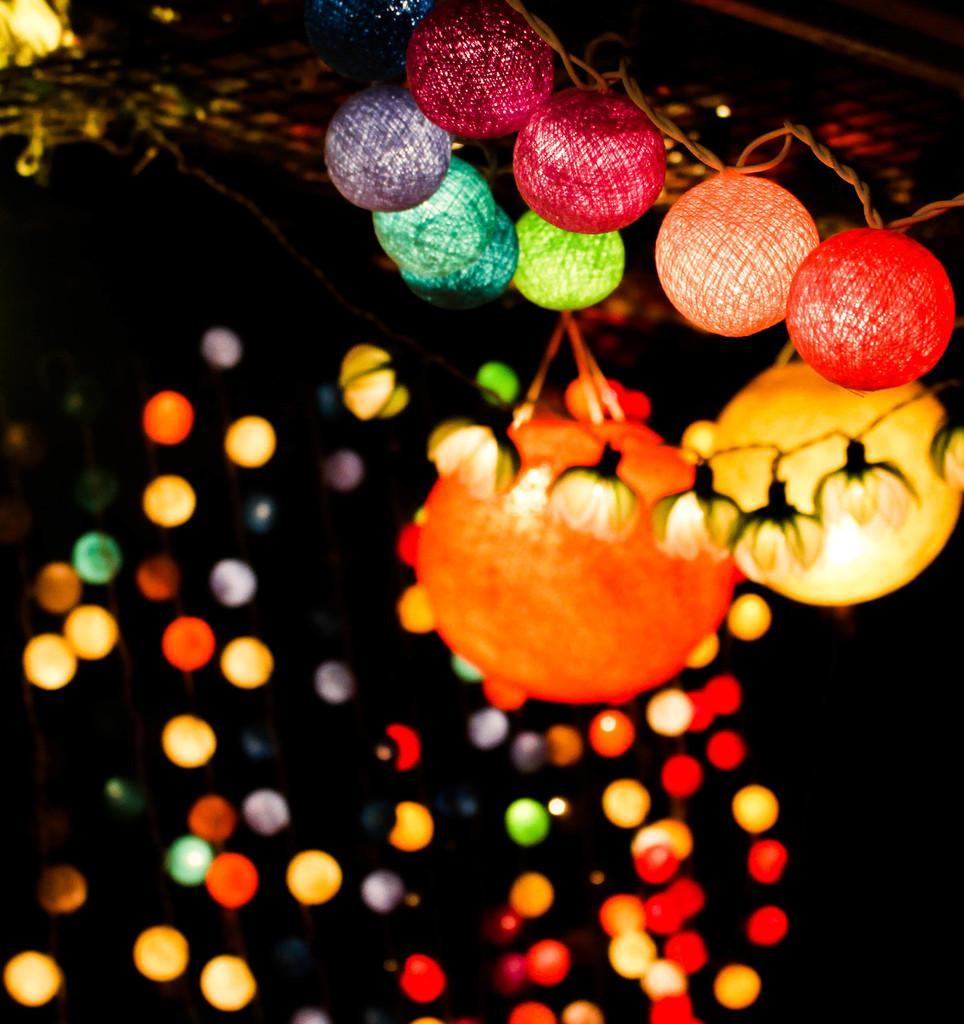Could you give a brief overview of what you see in this image? This image consists of lights. 